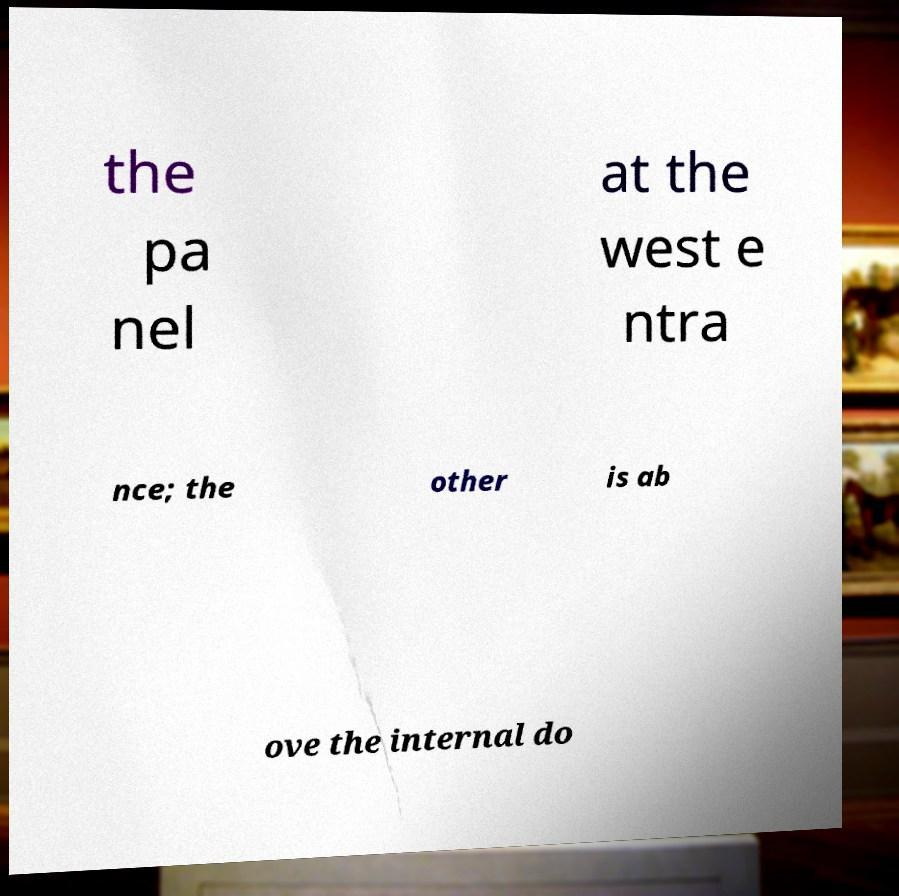There's text embedded in this image that I need extracted. Can you transcribe it verbatim? the pa nel at the west e ntra nce; the other is ab ove the internal do 